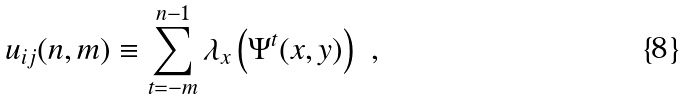Convert formula to latex. <formula><loc_0><loc_0><loc_500><loc_500>u _ { i j } ( n , m ) \equiv \sum _ { t = - m } ^ { n - 1 } \lambda _ { x } \left ( \Psi ^ { t } ( x , y ) \right ) \ ,</formula> 